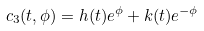<formula> <loc_0><loc_0><loc_500><loc_500>c _ { 3 } ( t , \phi ) = h ( t ) e ^ { \phi } + k ( t ) e ^ { - \phi }</formula> 